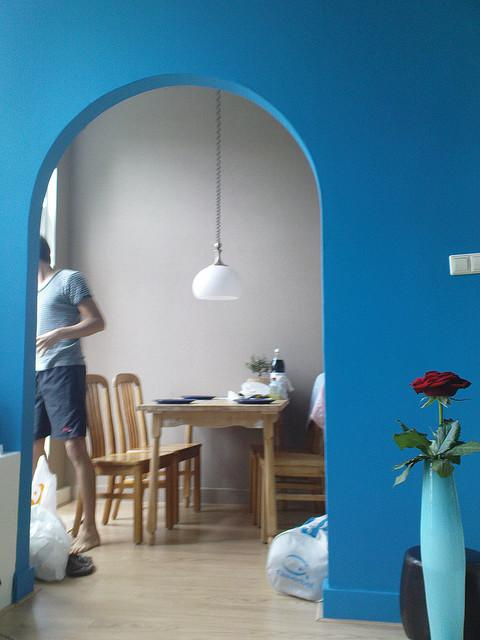What is furthest to the right? vase 